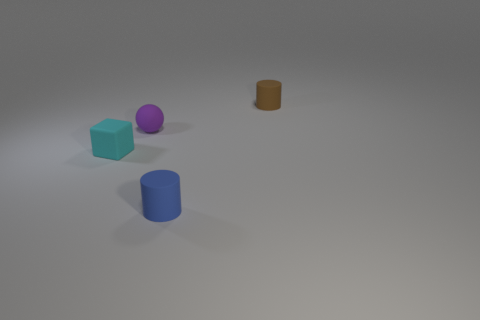Can you describe the texture differences among the objects? Certainly, the blue block and blue cylinder exhibit a smoother, matte-like texture, while the other objects have a more grainy texture with less uniform surfaces. 